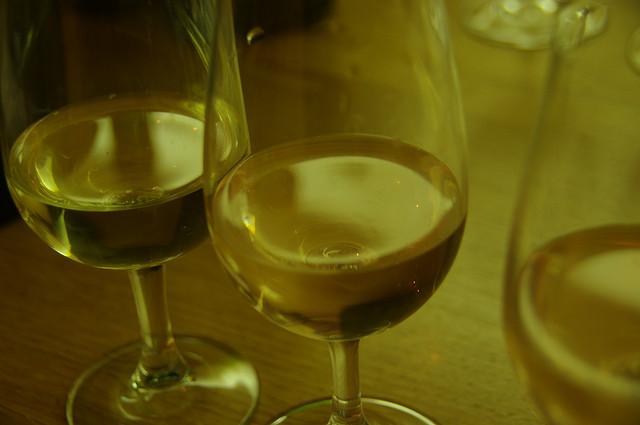How many glasses are there?
Short answer required. 3. What beverage is in these glasses?
Quick response, please. Wine. Is it white wine?
Answer briefly. Yes. Is this wine white or dark wine?
Be succinct. White. What color is the table?
Quick response, please. Brown. Do the wine glasses have a name on them?
Short answer required. No. Are the cups full?
Be succinct. No. 